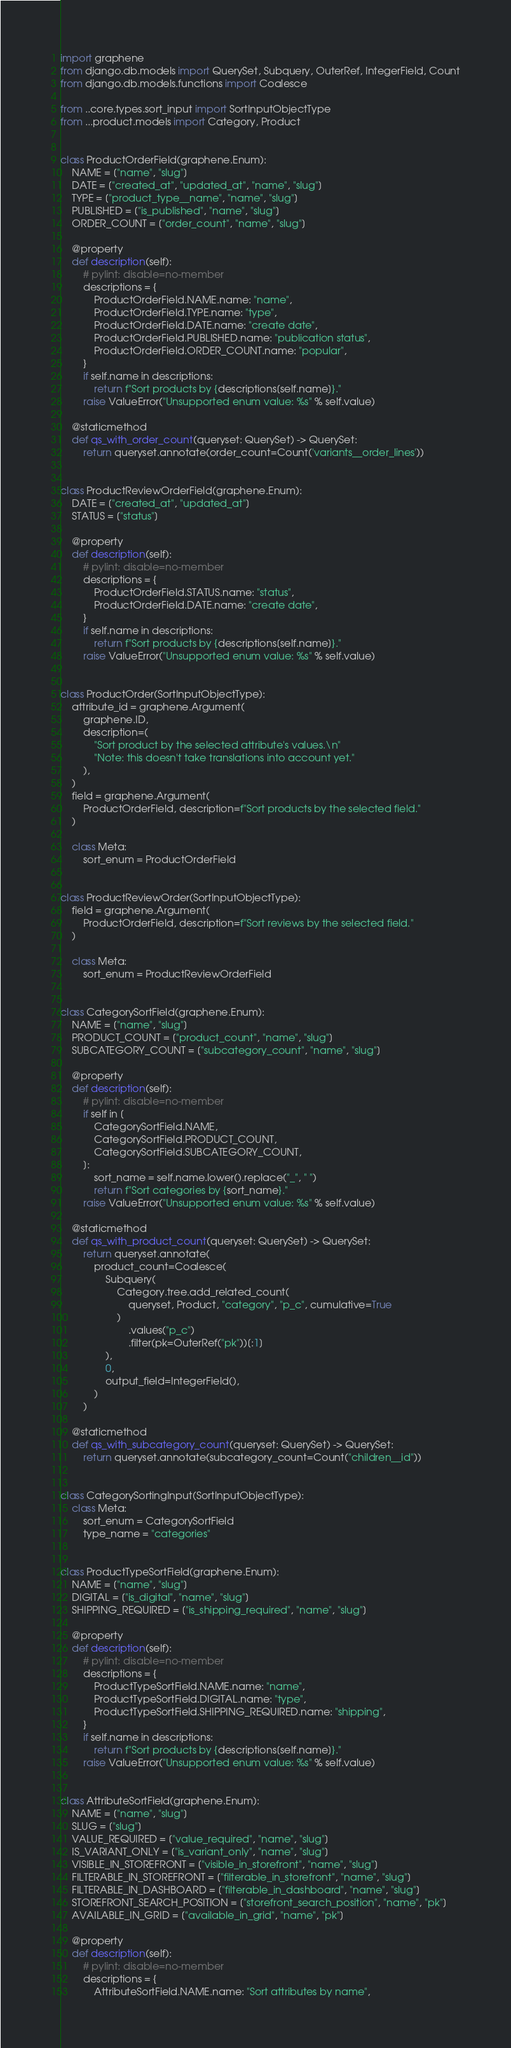<code> <loc_0><loc_0><loc_500><loc_500><_Python_>import graphene
from django.db.models import QuerySet, Subquery, OuterRef, IntegerField, Count
from django.db.models.functions import Coalesce

from ..core.types.sort_input import SortInputObjectType
from ...product.models import Category, Product


class ProductOrderField(graphene.Enum):
    NAME = ["name", "slug"]
    DATE = ["created_at", "updated_at", "name", "slug"]
    TYPE = ["product_type__name", "name", "slug"]
    PUBLISHED = ["is_published", "name", "slug"]
    ORDER_COUNT = ["order_count", "name", "slug"]

    @property
    def description(self):
        # pylint: disable=no-member
        descriptions = {
            ProductOrderField.NAME.name: "name",
            ProductOrderField.TYPE.name: "type",
            ProductOrderField.DATE.name: "create date",
            ProductOrderField.PUBLISHED.name: "publication status",
            ProductOrderField.ORDER_COUNT.name: "popular",
        }
        if self.name in descriptions:
            return f"Sort products by {descriptions[self.name]}."
        raise ValueError("Unsupported enum value: %s" % self.value)

    @staticmethod
    def qs_with_order_count(queryset: QuerySet) -> QuerySet:
        return queryset.annotate(order_count=Count('variants__order_lines'))


class ProductReviewOrderField(graphene.Enum):
    DATE = ["created_at", "updated_at"]
    STATUS = ["status"]

    @property
    def description(self):
        # pylint: disable=no-member
        descriptions = {
            ProductOrderField.STATUS.name: "status",
            ProductOrderField.DATE.name: "create date",
        }
        if self.name in descriptions:
            return f"Sort products by {descriptions[self.name]}."
        raise ValueError("Unsupported enum value: %s" % self.value)


class ProductOrder(SortInputObjectType):
    attribute_id = graphene.Argument(
        graphene.ID,
        description=(
            "Sort product by the selected attribute's values.\n"
            "Note: this doesn't take translations into account yet."
        ),
    )
    field = graphene.Argument(
        ProductOrderField, description=f"Sort products by the selected field."
    )

    class Meta:
        sort_enum = ProductOrderField


class ProductReviewOrder(SortInputObjectType):
    field = graphene.Argument(
        ProductOrderField, description=f"Sort reviews by the selected field."
    )

    class Meta:
        sort_enum = ProductReviewOrderField


class CategorySortField(graphene.Enum):
    NAME = ["name", "slug"]
    PRODUCT_COUNT = ["product_count", "name", "slug"]
    SUBCATEGORY_COUNT = ["subcategory_count", "name", "slug"]

    @property
    def description(self):
        # pylint: disable=no-member
        if self in [
            CategorySortField.NAME,
            CategorySortField.PRODUCT_COUNT,
            CategorySortField.SUBCATEGORY_COUNT,
        ]:
            sort_name = self.name.lower().replace("_", " ")
            return f"Sort categories by {sort_name}."
        raise ValueError("Unsupported enum value: %s" % self.value)

    @staticmethod
    def qs_with_product_count(queryset: QuerySet) -> QuerySet:
        return queryset.annotate(
            product_count=Coalesce(
                Subquery(
                    Category.tree.add_related_count(
                        queryset, Product, "category", "p_c", cumulative=True
                    )
                        .values("p_c")
                        .filter(pk=OuterRef("pk"))[:1]
                ),
                0,
                output_field=IntegerField(),
            )
        )

    @staticmethod
    def qs_with_subcategory_count(queryset: QuerySet) -> QuerySet:
        return queryset.annotate(subcategory_count=Count("children__id"))


class CategorySortingInput(SortInputObjectType):
    class Meta:
        sort_enum = CategorySortField
        type_name = "categories"


class ProductTypeSortField(graphene.Enum):
    NAME = ["name", "slug"]
    DIGITAL = ["is_digital", "name", "slug"]
    SHIPPING_REQUIRED = ["is_shipping_required", "name", "slug"]

    @property
    def description(self):
        # pylint: disable=no-member
        descriptions = {
            ProductTypeSortField.NAME.name: "name",
            ProductTypeSortField.DIGITAL.name: "type",
            ProductTypeSortField.SHIPPING_REQUIRED.name: "shipping",
        }
        if self.name in descriptions:
            return f"Sort products by {descriptions[self.name]}."
        raise ValueError("Unsupported enum value: %s" % self.value)


class AttributeSortField(graphene.Enum):
    NAME = ["name", "slug"]
    SLUG = ["slug"]
    VALUE_REQUIRED = ["value_required", "name", "slug"]
    IS_VARIANT_ONLY = ["is_variant_only", "name", "slug"]
    VISIBLE_IN_STOREFRONT = ["visible_in_storefront", "name", "slug"]
    FILTERABLE_IN_STOREFRONT = ["filterable_in_storefront", "name", "slug"]
    FILTERABLE_IN_DASHBOARD = ["filterable_in_dashboard", "name", "slug"]
    STOREFRONT_SEARCH_POSITION = ["storefront_search_position", "name", "pk"]
    AVAILABLE_IN_GRID = ["available_in_grid", "name", "pk"]

    @property
    def description(self):
        # pylint: disable=no-member
        descriptions = {
            AttributeSortField.NAME.name: "Sort attributes by name",</code> 